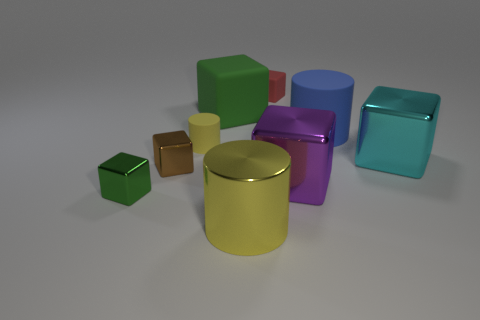There is a purple thing that is the same size as the cyan shiny block; what is its shape?
Make the answer very short. Cube. Are there any blue matte things of the same shape as the large cyan shiny thing?
Your response must be concise. No. Is the tiny brown object made of the same material as the small cylinder in front of the red matte object?
Offer a very short reply. No. What color is the matte cylinder to the right of the small thing that is on the right side of the yellow cylinder that is in front of the yellow matte cylinder?
Your answer should be compact. Blue. What is the material of the brown thing that is the same size as the red matte object?
Provide a short and direct response. Metal. What number of green cubes have the same material as the large cyan block?
Give a very brief answer. 1. Does the yellow metallic cylinder that is in front of the big purple metal thing have the same size as the matte block on the right side of the green rubber thing?
Give a very brief answer. No. What color is the block that is right of the large blue rubber cylinder?
Your response must be concise. Cyan. What material is the tiny block that is the same color as the large matte block?
Make the answer very short. Metal. How many shiny things are the same color as the tiny rubber cylinder?
Offer a very short reply. 1. 